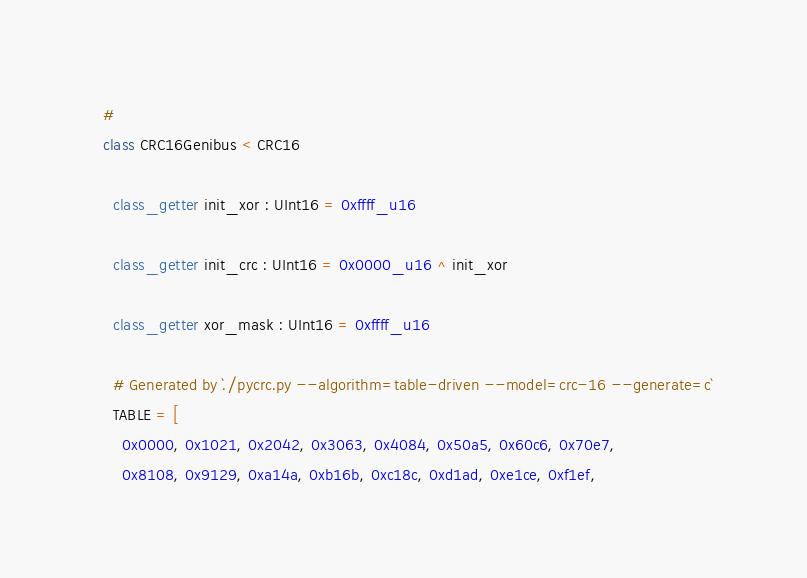Convert code to text. <code><loc_0><loc_0><loc_500><loc_500><_Crystal_>  #
  class CRC16Genibus < CRC16

    class_getter init_xor : UInt16 = 0xffff_u16

    class_getter init_crc : UInt16 = 0x0000_u16 ^ init_xor

    class_getter xor_mask : UInt16 = 0xffff_u16

    # Generated by `./pycrc.py --algorithm=table-driven --model=crc-16 --generate=c`
    TABLE = [
      0x0000, 0x1021, 0x2042, 0x3063, 0x4084, 0x50a5, 0x60c6, 0x70e7,
      0x8108, 0x9129, 0xa14a, 0xb16b, 0xc18c, 0xd1ad, 0xe1ce, 0xf1ef,</code> 